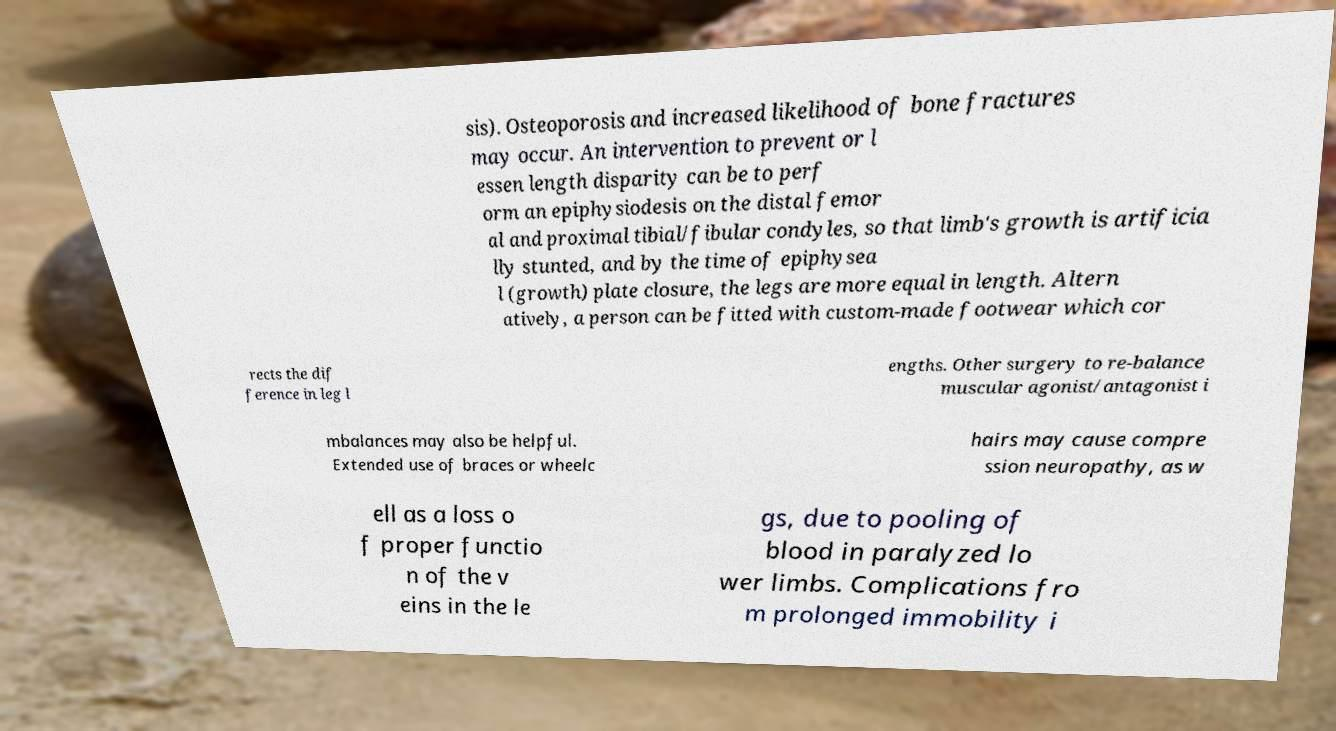I need the written content from this picture converted into text. Can you do that? sis). Osteoporosis and increased likelihood of bone fractures may occur. An intervention to prevent or l essen length disparity can be to perf orm an epiphysiodesis on the distal femor al and proximal tibial/fibular condyles, so that limb's growth is artificia lly stunted, and by the time of epiphysea l (growth) plate closure, the legs are more equal in length. Altern atively, a person can be fitted with custom-made footwear which cor rects the dif ference in leg l engths. Other surgery to re-balance muscular agonist/antagonist i mbalances may also be helpful. Extended use of braces or wheelc hairs may cause compre ssion neuropathy, as w ell as a loss o f proper functio n of the v eins in the le gs, due to pooling of blood in paralyzed lo wer limbs. Complications fro m prolonged immobility i 